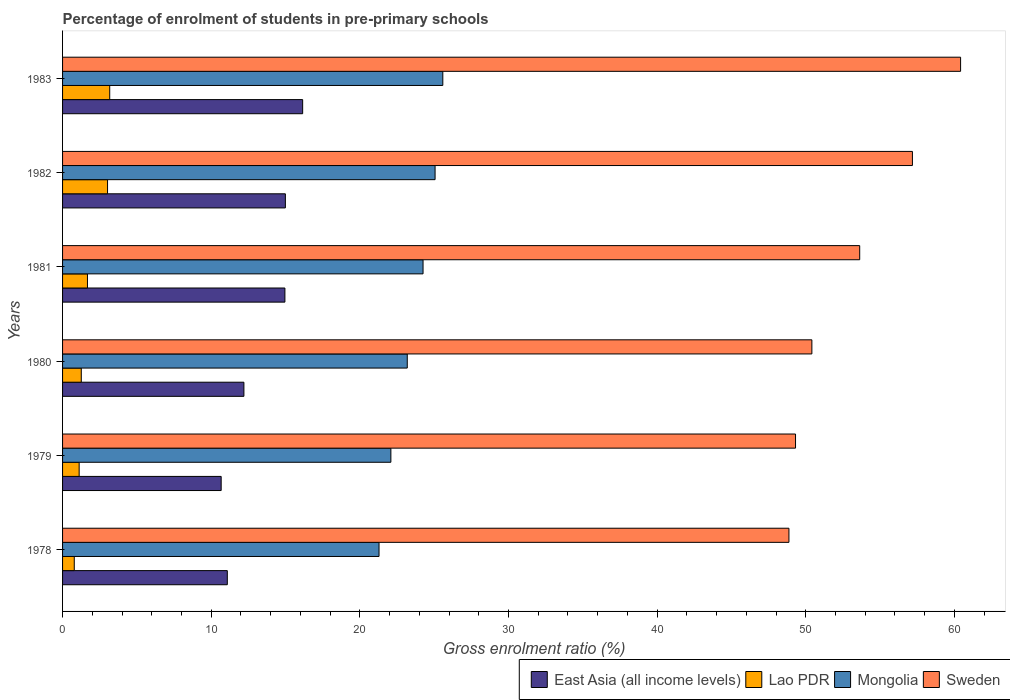How many groups of bars are there?
Ensure brevity in your answer.  6. How many bars are there on the 6th tick from the bottom?
Your response must be concise. 4. In how many cases, is the number of bars for a given year not equal to the number of legend labels?
Your answer should be compact. 0. What is the percentage of students enrolled in pre-primary schools in East Asia (all income levels) in 1981?
Your answer should be very brief. 14.96. Across all years, what is the maximum percentage of students enrolled in pre-primary schools in Mongolia?
Your answer should be compact. 25.58. Across all years, what is the minimum percentage of students enrolled in pre-primary schools in East Asia (all income levels)?
Make the answer very short. 10.67. In which year was the percentage of students enrolled in pre-primary schools in Lao PDR maximum?
Your answer should be compact. 1983. In which year was the percentage of students enrolled in pre-primary schools in Sweden minimum?
Offer a terse response. 1978. What is the total percentage of students enrolled in pre-primary schools in Sweden in the graph?
Offer a very short reply. 319.82. What is the difference between the percentage of students enrolled in pre-primary schools in Sweden in 1979 and that in 1980?
Offer a very short reply. -1.1. What is the difference between the percentage of students enrolled in pre-primary schools in Sweden in 1978 and the percentage of students enrolled in pre-primary schools in Mongolia in 1982?
Provide a succinct answer. 23.81. What is the average percentage of students enrolled in pre-primary schools in Sweden per year?
Your answer should be very brief. 53.3. In the year 1981, what is the difference between the percentage of students enrolled in pre-primary schools in Sweden and percentage of students enrolled in pre-primary schools in East Asia (all income levels)?
Keep it short and to the point. 38.67. In how many years, is the percentage of students enrolled in pre-primary schools in East Asia (all income levels) greater than 34 %?
Offer a terse response. 0. What is the ratio of the percentage of students enrolled in pre-primary schools in Mongolia in 1981 to that in 1983?
Ensure brevity in your answer.  0.95. Is the percentage of students enrolled in pre-primary schools in Mongolia in 1980 less than that in 1983?
Ensure brevity in your answer.  Yes. Is the difference between the percentage of students enrolled in pre-primary schools in Sweden in 1981 and 1982 greater than the difference between the percentage of students enrolled in pre-primary schools in East Asia (all income levels) in 1981 and 1982?
Your answer should be very brief. No. What is the difference between the highest and the second highest percentage of students enrolled in pre-primary schools in Lao PDR?
Your answer should be compact. 0.15. What is the difference between the highest and the lowest percentage of students enrolled in pre-primary schools in Lao PDR?
Your answer should be very brief. 2.38. Is the sum of the percentage of students enrolled in pre-primary schools in Sweden in 1979 and 1983 greater than the maximum percentage of students enrolled in pre-primary schools in Lao PDR across all years?
Your answer should be very brief. Yes. What does the 4th bar from the top in 1979 represents?
Provide a succinct answer. East Asia (all income levels). What does the 3rd bar from the bottom in 1983 represents?
Offer a very short reply. Mongolia. Is it the case that in every year, the sum of the percentage of students enrolled in pre-primary schools in Mongolia and percentage of students enrolled in pre-primary schools in Sweden is greater than the percentage of students enrolled in pre-primary schools in East Asia (all income levels)?
Provide a short and direct response. Yes. How many bars are there?
Provide a short and direct response. 24. Are all the bars in the graph horizontal?
Your answer should be very brief. Yes. How many years are there in the graph?
Ensure brevity in your answer.  6. Are the values on the major ticks of X-axis written in scientific E-notation?
Your answer should be compact. No. How many legend labels are there?
Provide a short and direct response. 4. How are the legend labels stacked?
Your answer should be compact. Horizontal. What is the title of the graph?
Ensure brevity in your answer.  Percentage of enrolment of students in pre-primary schools. What is the label or title of the X-axis?
Ensure brevity in your answer.  Gross enrolment ratio (%). What is the label or title of the Y-axis?
Your answer should be very brief. Years. What is the Gross enrolment ratio (%) in East Asia (all income levels) in 1978?
Your response must be concise. 11.08. What is the Gross enrolment ratio (%) in Lao PDR in 1978?
Provide a short and direct response. 0.79. What is the Gross enrolment ratio (%) of Mongolia in 1978?
Provide a short and direct response. 21.29. What is the Gross enrolment ratio (%) in Sweden in 1978?
Provide a short and direct response. 48.87. What is the Gross enrolment ratio (%) in East Asia (all income levels) in 1979?
Provide a short and direct response. 10.67. What is the Gross enrolment ratio (%) in Lao PDR in 1979?
Ensure brevity in your answer.  1.12. What is the Gross enrolment ratio (%) in Mongolia in 1979?
Provide a short and direct response. 22.09. What is the Gross enrolment ratio (%) in Sweden in 1979?
Your answer should be very brief. 49.31. What is the Gross enrolment ratio (%) in East Asia (all income levels) in 1980?
Offer a very short reply. 12.2. What is the Gross enrolment ratio (%) of Lao PDR in 1980?
Your answer should be compact. 1.26. What is the Gross enrolment ratio (%) in Mongolia in 1980?
Offer a very short reply. 23.19. What is the Gross enrolment ratio (%) in Sweden in 1980?
Your answer should be compact. 50.41. What is the Gross enrolment ratio (%) of East Asia (all income levels) in 1981?
Ensure brevity in your answer.  14.96. What is the Gross enrolment ratio (%) of Lao PDR in 1981?
Offer a terse response. 1.68. What is the Gross enrolment ratio (%) of Mongolia in 1981?
Provide a short and direct response. 24.25. What is the Gross enrolment ratio (%) in Sweden in 1981?
Ensure brevity in your answer.  53.63. What is the Gross enrolment ratio (%) in East Asia (all income levels) in 1982?
Your answer should be compact. 14.99. What is the Gross enrolment ratio (%) of Lao PDR in 1982?
Your answer should be very brief. 3.03. What is the Gross enrolment ratio (%) of Mongolia in 1982?
Make the answer very short. 25.06. What is the Gross enrolment ratio (%) in Sweden in 1982?
Your response must be concise. 57.18. What is the Gross enrolment ratio (%) of East Asia (all income levels) in 1983?
Make the answer very short. 16.15. What is the Gross enrolment ratio (%) of Lao PDR in 1983?
Your answer should be compact. 3.17. What is the Gross enrolment ratio (%) of Mongolia in 1983?
Your response must be concise. 25.58. What is the Gross enrolment ratio (%) in Sweden in 1983?
Your response must be concise. 60.42. Across all years, what is the maximum Gross enrolment ratio (%) in East Asia (all income levels)?
Your answer should be compact. 16.15. Across all years, what is the maximum Gross enrolment ratio (%) in Lao PDR?
Make the answer very short. 3.17. Across all years, what is the maximum Gross enrolment ratio (%) of Mongolia?
Give a very brief answer. 25.58. Across all years, what is the maximum Gross enrolment ratio (%) of Sweden?
Your answer should be very brief. 60.42. Across all years, what is the minimum Gross enrolment ratio (%) in East Asia (all income levels)?
Keep it short and to the point. 10.67. Across all years, what is the minimum Gross enrolment ratio (%) in Lao PDR?
Give a very brief answer. 0.79. Across all years, what is the minimum Gross enrolment ratio (%) of Mongolia?
Ensure brevity in your answer.  21.29. Across all years, what is the minimum Gross enrolment ratio (%) in Sweden?
Provide a short and direct response. 48.87. What is the total Gross enrolment ratio (%) in East Asia (all income levels) in the graph?
Provide a short and direct response. 80.06. What is the total Gross enrolment ratio (%) of Lao PDR in the graph?
Your answer should be compact. 11.04. What is the total Gross enrolment ratio (%) in Mongolia in the graph?
Offer a very short reply. 141.47. What is the total Gross enrolment ratio (%) of Sweden in the graph?
Ensure brevity in your answer.  319.82. What is the difference between the Gross enrolment ratio (%) of East Asia (all income levels) in 1978 and that in 1979?
Give a very brief answer. 0.41. What is the difference between the Gross enrolment ratio (%) of Lao PDR in 1978 and that in 1979?
Give a very brief answer. -0.33. What is the difference between the Gross enrolment ratio (%) of Mongolia in 1978 and that in 1979?
Ensure brevity in your answer.  -0.8. What is the difference between the Gross enrolment ratio (%) of Sweden in 1978 and that in 1979?
Offer a very short reply. -0.44. What is the difference between the Gross enrolment ratio (%) in East Asia (all income levels) in 1978 and that in 1980?
Provide a short and direct response. -1.12. What is the difference between the Gross enrolment ratio (%) of Lao PDR in 1978 and that in 1980?
Provide a short and direct response. -0.47. What is the difference between the Gross enrolment ratio (%) in Mongolia in 1978 and that in 1980?
Your answer should be very brief. -1.9. What is the difference between the Gross enrolment ratio (%) in Sweden in 1978 and that in 1980?
Offer a terse response. -1.54. What is the difference between the Gross enrolment ratio (%) of East Asia (all income levels) in 1978 and that in 1981?
Keep it short and to the point. -3.87. What is the difference between the Gross enrolment ratio (%) of Lao PDR in 1978 and that in 1981?
Your answer should be compact. -0.89. What is the difference between the Gross enrolment ratio (%) in Mongolia in 1978 and that in 1981?
Provide a short and direct response. -2.96. What is the difference between the Gross enrolment ratio (%) of Sweden in 1978 and that in 1981?
Make the answer very short. -4.76. What is the difference between the Gross enrolment ratio (%) in East Asia (all income levels) in 1978 and that in 1982?
Offer a very short reply. -3.91. What is the difference between the Gross enrolment ratio (%) of Lao PDR in 1978 and that in 1982?
Provide a short and direct response. -2.24. What is the difference between the Gross enrolment ratio (%) of Mongolia in 1978 and that in 1982?
Provide a short and direct response. -3.77. What is the difference between the Gross enrolment ratio (%) of Sweden in 1978 and that in 1982?
Provide a short and direct response. -8.31. What is the difference between the Gross enrolment ratio (%) of East Asia (all income levels) in 1978 and that in 1983?
Your answer should be compact. -5.07. What is the difference between the Gross enrolment ratio (%) in Lao PDR in 1978 and that in 1983?
Make the answer very short. -2.38. What is the difference between the Gross enrolment ratio (%) of Mongolia in 1978 and that in 1983?
Offer a very short reply. -4.29. What is the difference between the Gross enrolment ratio (%) in Sweden in 1978 and that in 1983?
Ensure brevity in your answer.  -11.55. What is the difference between the Gross enrolment ratio (%) in East Asia (all income levels) in 1979 and that in 1980?
Provide a succinct answer. -1.53. What is the difference between the Gross enrolment ratio (%) of Lao PDR in 1979 and that in 1980?
Keep it short and to the point. -0.14. What is the difference between the Gross enrolment ratio (%) of Mongolia in 1979 and that in 1980?
Your response must be concise. -1.1. What is the difference between the Gross enrolment ratio (%) of Sweden in 1979 and that in 1980?
Your answer should be very brief. -1.1. What is the difference between the Gross enrolment ratio (%) in East Asia (all income levels) in 1979 and that in 1981?
Offer a terse response. -4.29. What is the difference between the Gross enrolment ratio (%) in Lao PDR in 1979 and that in 1981?
Offer a very short reply. -0.56. What is the difference between the Gross enrolment ratio (%) in Mongolia in 1979 and that in 1981?
Make the answer very short. -2.16. What is the difference between the Gross enrolment ratio (%) of Sweden in 1979 and that in 1981?
Keep it short and to the point. -4.32. What is the difference between the Gross enrolment ratio (%) of East Asia (all income levels) in 1979 and that in 1982?
Give a very brief answer. -4.32. What is the difference between the Gross enrolment ratio (%) in Lao PDR in 1979 and that in 1982?
Your answer should be very brief. -1.91. What is the difference between the Gross enrolment ratio (%) in Mongolia in 1979 and that in 1982?
Offer a very short reply. -2.97. What is the difference between the Gross enrolment ratio (%) in Sweden in 1979 and that in 1982?
Provide a succinct answer. -7.86. What is the difference between the Gross enrolment ratio (%) of East Asia (all income levels) in 1979 and that in 1983?
Give a very brief answer. -5.48. What is the difference between the Gross enrolment ratio (%) of Lao PDR in 1979 and that in 1983?
Ensure brevity in your answer.  -2.06. What is the difference between the Gross enrolment ratio (%) of Mongolia in 1979 and that in 1983?
Provide a short and direct response. -3.49. What is the difference between the Gross enrolment ratio (%) in Sweden in 1979 and that in 1983?
Provide a short and direct response. -11.1. What is the difference between the Gross enrolment ratio (%) of East Asia (all income levels) in 1980 and that in 1981?
Give a very brief answer. -2.76. What is the difference between the Gross enrolment ratio (%) of Lao PDR in 1980 and that in 1981?
Make the answer very short. -0.42. What is the difference between the Gross enrolment ratio (%) of Mongolia in 1980 and that in 1981?
Your answer should be compact. -1.06. What is the difference between the Gross enrolment ratio (%) in Sweden in 1980 and that in 1981?
Ensure brevity in your answer.  -3.22. What is the difference between the Gross enrolment ratio (%) of East Asia (all income levels) in 1980 and that in 1982?
Offer a very short reply. -2.79. What is the difference between the Gross enrolment ratio (%) of Lao PDR in 1980 and that in 1982?
Provide a short and direct response. -1.77. What is the difference between the Gross enrolment ratio (%) of Mongolia in 1980 and that in 1982?
Offer a very short reply. -1.87. What is the difference between the Gross enrolment ratio (%) in Sweden in 1980 and that in 1982?
Offer a very short reply. -6.76. What is the difference between the Gross enrolment ratio (%) in East Asia (all income levels) in 1980 and that in 1983?
Provide a succinct answer. -3.95. What is the difference between the Gross enrolment ratio (%) in Lao PDR in 1980 and that in 1983?
Your answer should be very brief. -1.91. What is the difference between the Gross enrolment ratio (%) in Mongolia in 1980 and that in 1983?
Your response must be concise. -2.39. What is the difference between the Gross enrolment ratio (%) of Sweden in 1980 and that in 1983?
Offer a terse response. -10.01. What is the difference between the Gross enrolment ratio (%) in East Asia (all income levels) in 1981 and that in 1982?
Your answer should be very brief. -0.03. What is the difference between the Gross enrolment ratio (%) of Lao PDR in 1981 and that in 1982?
Your answer should be compact. -1.35. What is the difference between the Gross enrolment ratio (%) in Mongolia in 1981 and that in 1982?
Your answer should be compact. -0.81. What is the difference between the Gross enrolment ratio (%) of Sweden in 1981 and that in 1982?
Your answer should be compact. -3.55. What is the difference between the Gross enrolment ratio (%) of East Asia (all income levels) in 1981 and that in 1983?
Ensure brevity in your answer.  -1.19. What is the difference between the Gross enrolment ratio (%) of Lao PDR in 1981 and that in 1983?
Give a very brief answer. -1.5. What is the difference between the Gross enrolment ratio (%) of Mongolia in 1981 and that in 1983?
Make the answer very short. -1.33. What is the difference between the Gross enrolment ratio (%) in Sweden in 1981 and that in 1983?
Ensure brevity in your answer.  -6.79. What is the difference between the Gross enrolment ratio (%) of East Asia (all income levels) in 1982 and that in 1983?
Make the answer very short. -1.16. What is the difference between the Gross enrolment ratio (%) of Lao PDR in 1982 and that in 1983?
Keep it short and to the point. -0.15. What is the difference between the Gross enrolment ratio (%) in Mongolia in 1982 and that in 1983?
Provide a succinct answer. -0.52. What is the difference between the Gross enrolment ratio (%) of Sweden in 1982 and that in 1983?
Offer a very short reply. -3.24. What is the difference between the Gross enrolment ratio (%) in East Asia (all income levels) in 1978 and the Gross enrolment ratio (%) in Lao PDR in 1979?
Keep it short and to the point. 9.97. What is the difference between the Gross enrolment ratio (%) in East Asia (all income levels) in 1978 and the Gross enrolment ratio (%) in Mongolia in 1979?
Make the answer very short. -11. What is the difference between the Gross enrolment ratio (%) of East Asia (all income levels) in 1978 and the Gross enrolment ratio (%) of Sweden in 1979?
Your answer should be compact. -38.23. What is the difference between the Gross enrolment ratio (%) in Lao PDR in 1978 and the Gross enrolment ratio (%) in Mongolia in 1979?
Ensure brevity in your answer.  -21.3. What is the difference between the Gross enrolment ratio (%) in Lao PDR in 1978 and the Gross enrolment ratio (%) in Sweden in 1979?
Make the answer very short. -48.53. What is the difference between the Gross enrolment ratio (%) of Mongolia in 1978 and the Gross enrolment ratio (%) of Sweden in 1979?
Keep it short and to the point. -28.02. What is the difference between the Gross enrolment ratio (%) of East Asia (all income levels) in 1978 and the Gross enrolment ratio (%) of Lao PDR in 1980?
Provide a succinct answer. 9.83. What is the difference between the Gross enrolment ratio (%) of East Asia (all income levels) in 1978 and the Gross enrolment ratio (%) of Mongolia in 1980?
Offer a very short reply. -12.11. What is the difference between the Gross enrolment ratio (%) in East Asia (all income levels) in 1978 and the Gross enrolment ratio (%) in Sweden in 1980?
Ensure brevity in your answer.  -39.33. What is the difference between the Gross enrolment ratio (%) in Lao PDR in 1978 and the Gross enrolment ratio (%) in Mongolia in 1980?
Offer a terse response. -22.4. What is the difference between the Gross enrolment ratio (%) in Lao PDR in 1978 and the Gross enrolment ratio (%) in Sweden in 1980?
Your answer should be very brief. -49.62. What is the difference between the Gross enrolment ratio (%) in Mongolia in 1978 and the Gross enrolment ratio (%) in Sweden in 1980?
Ensure brevity in your answer.  -29.12. What is the difference between the Gross enrolment ratio (%) in East Asia (all income levels) in 1978 and the Gross enrolment ratio (%) in Lao PDR in 1981?
Your answer should be very brief. 9.41. What is the difference between the Gross enrolment ratio (%) of East Asia (all income levels) in 1978 and the Gross enrolment ratio (%) of Mongolia in 1981?
Provide a succinct answer. -13.17. What is the difference between the Gross enrolment ratio (%) in East Asia (all income levels) in 1978 and the Gross enrolment ratio (%) in Sweden in 1981?
Give a very brief answer. -42.55. What is the difference between the Gross enrolment ratio (%) in Lao PDR in 1978 and the Gross enrolment ratio (%) in Mongolia in 1981?
Offer a very short reply. -23.46. What is the difference between the Gross enrolment ratio (%) of Lao PDR in 1978 and the Gross enrolment ratio (%) of Sweden in 1981?
Offer a terse response. -52.84. What is the difference between the Gross enrolment ratio (%) of Mongolia in 1978 and the Gross enrolment ratio (%) of Sweden in 1981?
Provide a succinct answer. -32.34. What is the difference between the Gross enrolment ratio (%) of East Asia (all income levels) in 1978 and the Gross enrolment ratio (%) of Lao PDR in 1982?
Offer a terse response. 8.06. What is the difference between the Gross enrolment ratio (%) in East Asia (all income levels) in 1978 and the Gross enrolment ratio (%) in Mongolia in 1982?
Give a very brief answer. -13.98. What is the difference between the Gross enrolment ratio (%) in East Asia (all income levels) in 1978 and the Gross enrolment ratio (%) in Sweden in 1982?
Your answer should be compact. -46.09. What is the difference between the Gross enrolment ratio (%) in Lao PDR in 1978 and the Gross enrolment ratio (%) in Mongolia in 1982?
Provide a short and direct response. -24.27. What is the difference between the Gross enrolment ratio (%) of Lao PDR in 1978 and the Gross enrolment ratio (%) of Sweden in 1982?
Give a very brief answer. -56.39. What is the difference between the Gross enrolment ratio (%) in Mongolia in 1978 and the Gross enrolment ratio (%) in Sweden in 1982?
Your answer should be very brief. -35.88. What is the difference between the Gross enrolment ratio (%) of East Asia (all income levels) in 1978 and the Gross enrolment ratio (%) of Lao PDR in 1983?
Your answer should be very brief. 7.91. What is the difference between the Gross enrolment ratio (%) in East Asia (all income levels) in 1978 and the Gross enrolment ratio (%) in Mongolia in 1983?
Your response must be concise. -14.5. What is the difference between the Gross enrolment ratio (%) in East Asia (all income levels) in 1978 and the Gross enrolment ratio (%) in Sweden in 1983?
Offer a very short reply. -49.33. What is the difference between the Gross enrolment ratio (%) of Lao PDR in 1978 and the Gross enrolment ratio (%) of Mongolia in 1983?
Ensure brevity in your answer.  -24.79. What is the difference between the Gross enrolment ratio (%) in Lao PDR in 1978 and the Gross enrolment ratio (%) in Sweden in 1983?
Offer a terse response. -59.63. What is the difference between the Gross enrolment ratio (%) of Mongolia in 1978 and the Gross enrolment ratio (%) of Sweden in 1983?
Make the answer very short. -39.13. What is the difference between the Gross enrolment ratio (%) of East Asia (all income levels) in 1979 and the Gross enrolment ratio (%) of Lao PDR in 1980?
Your response must be concise. 9.41. What is the difference between the Gross enrolment ratio (%) of East Asia (all income levels) in 1979 and the Gross enrolment ratio (%) of Mongolia in 1980?
Keep it short and to the point. -12.52. What is the difference between the Gross enrolment ratio (%) of East Asia (all income levels) in 1979 and the Gross enrolment ratio (%) of Sweden in 1980?
Your response must be concise. -39.74. What is the difference between the Gross enrolment ratio (%) in Lao PDR in 1979 and the Gross enrolment ratio (%) in Mongolia in 1980?
Offer a very short reply. -22.07. What is the difference between the Gross enrolment ratio (%) of Lao PDR in 1979 and the Gross enrolment ratio (%) of Sweden in 1980?
Your answer should be very brief. -49.3. What is the difference between the Gross enrolment ratio (%) of Mongolia in 1979 and the Gross enrolment ratio (%) of Sweden in 1980?
Your answer should be compact. -28.32. What is the difference between the Gross enrolment ratio (%) in East Asia (all income levels) in 1979 and the Gross enrolment ratio (%) in Lao PDR in 1981?
Provide a succinct answer. 9. What is the difference between the Gross enrolment ratio (%) of East Asia (all income levels) in 1979 and the Gross enrolment ratio (%) of Mongolia in 1981?
Your answer should be very brief. -13.58. What is the difference between the Gross enrolment ratio (%) in East Asia (all income levels) in 1979 and the Gross enrolment ratio (%) in Sweden in 1981?
Keep it short and to the point. -42.96. What is the difference between the Gross enrolment ratio (%) in Lao PDR in 1979 and the Gross enrolment ratio (%) in Mongolia in 1981?
Give a very brief answer. -23.14. What is the difference between the Gross enrolment ratio (%) of Lao PDR in 1979 and the Gross enrolment ratio (%) of Sweden in 1981?
Your answer should be very brief. -52.51. What is the difference between the Gross enrolment ratio (%) in Mongolia in 1979 and the Gross enrolment ratio (%) in Sweden in 1981?
Keep it short and to the point. -31.54. What is the difference between the Gross enrolment ratio (%) in East Asia (all income levels) in 1979 and the Gross enrolment ratio (%) in Lao PDR in 1982?
Offer a very short reply. 7.64. What is the difference between the Gross enrolment ratio (%) in East Asia (all income levels) in 1979 and the Gross enrolment ratio (%) in Mongolia in 1982?
Offer a terse response. -14.39. What is the difference between the Gross enrolment ratio (%) in East Asia (all income levels) in 1979 and the Gross enrolment ratio (%) in Sweden in 1982?
Give a very brief answer. -46.51. What is the difference between the Gross enrolment ratio (%) in Lao PDR in 1979 and the Gross enrolment ratio (%) in Mongolia in 1982?
Your response must be concise. -23.95. What is the difference between the Gross enrolment ratio (%) of Lao PDR in 1979 and the Gross enrolment ratio (%) of Sweden in 1982?
Offer a terse response. -56.06. What is the difference between the Gross enrolment ratio (%) of Mongolia in 1979 and the Gross enrolment ratio (%) of Sweden in 1982?
Your response must be concise. -35.09. What is the difference between the Gross enrolment ratio (%) of East Asia (all income levels) in 1979 and the Gross enrolment ratio (%) of Lao PDR in 1983?
Provide a succinct answer. 7.5. What is the difference between the Gross enrolment ratio (%) of East Asia (all income levels) in 1979 and the Gross enrolment ratio (%) of Mongolia in 1983?
Give a very brief answer. -14.91. What is the difference between the Gross enrolment ratio (%) of East Asia (all income levels) in 1979 and the Gross enrolment ratio (%) of Sweden in 1983?
Provide a succinct answer. -49.75. What is the difference between the Gross enrolment ratio (%) of Lao PDR in 1979 and the Gross enrolment ratio (%) of Mongolia in 1983?
Offer a terse response. -24.47. What is the difference between the Gross enrolment ratio (%) of Lao PDR in 1979 and the Gross enrolment ratio (%) of Sweden in 1983?
Offer a terse response. -59.3. What is the difference between the Gross enrolment ratio (%) of Mongolia in 1979 and the Gross enrolment ratio (%) of Sweden in 1983?
Offer a very short reply. -38.33. What is the difference between the Gross enrolment ratio (%) in East Asia (all income levels) in 1980 and the Gross enrolment ratio (%) in Lao PDR in 1981?
Offer a very short reply. 10.53. What is the difference between the Gross enrolment ratio (%) of East Asia (all income levels) in 1980 and the Gross enrolment ratio (%) of Mongolia in 1981?
Your answer should be very brief. -12.05. What is the difference between the Gross enrolment ratio (%) in East Asia (all income levels) in 1980 and the Gross enrolment ratio (%) in Sweden in 1981?
Offer a terse response. -41.43. What is the difference between the Gross enrolment ratio (%) in Lao PDR in 1980 and the Gross enrolment ratio (%) in Mongolia in 1981?
Ensure brevity in your answer.  -22.99. What is the difference between the Gross enrolment ratio (%) of Lao PDR in 1980 and the Gross enrolment ratio (%) of Sweden in 1981?
Make the answer very short. -52.37. What is the difference between the Gross enrolment ratio (%) in Mongolia in 1980 and the Gross enrolment ratio (%) in Sweden in 1981?
Your answer should be compact. -30.44. What is the difference between the Gross enrolment ratio (%) in East Asia (all income levels) in 1980 and the Gross enrolment ratio (%) in Lao PDR in 1982?
Give a very brief answer. 9.17. What is the difference between the Gross enrolment ratio (%) in East Asia (all income levels) in 1980 and the Gross enrolment ratio (%) in Mongolia in 1982?
Give a very brief answer. -12.86. What is the difference between the Gross enrolment ratio (%) of East Asia (all income levels) in 1980 and the Gross enrolment ratio (%) of Sweden in 1982?
Your answer should be compact. -44.98. What is the difference between the Gross enrolment ratio (%) in Lao PDR in 1980 and the Gross enrolment ratio (%) in Mongolia in 1982?
Offer a terse response. -23.8. What is the difference between the Gross enrolment ratio (%) of Lao PDR in 1980 and the Gross enrolment ratio (%) of Sweden in 1982?
Your answer should be compact. -55.92. What is the difference between the Gross enrolment ratio (%) in Mongolia in 1980 and the Gross enrolment ratio (%) in Sweden in 1982?
Provide a succinct answer. -33.99. What is the difference between the Gross enrolment ratio (%) of East Asia (all income levels) in 1980 and the Gross enrolment ratio (%) of Lao PDR in 1983?
Provide a succinct answer. 9.03. What is the difference between the Gross enrolment ratio (%) of East Asia (all income levels) in 1980 and the Gross enrolment ratio (%) of Mongolia in 1983?
Offer a very short reply. -13.38. What is the difference between the Gross enrolment ratio (%) of East Asia (all income levels) in 1980 and the Gross enrolment ratio (%) of Sweden in 1983?
Make the answer very short. -48.22. What is the difference between the Gross enrolment ratio (%) of Lao PDR in 1980 and the Gross enrolment ratio (%) of Mongolia in 1983?
Provide a succinct answer. -24.32. What is the difference between the Gross enrolment ratio (%) of Lao PDR in 1980 and the Gross enrolment ratio (%) of Sweden in 1983?
Provide a succinct answer. -59.16. What is the difference between the Gross enrolment ratio (%) in Mongolia in 1980 and the Gross enrolment ratio (%) in Sweden in 1983?
Your answer should be compact. -37.23. What is the difference between the Gross enrolment ratio (%) of East Asia (all income levels) in 1981 and the Gross enrolment ratio (%) of Lao PDR in 1982?
Keep it short and to the point. 11.93. What is the difference between the Gross enrolment ratio (%) in East Asia (all income levels) in 1981 and the Gross enrolment ratio (%) in Mongolia in 1982?
Keep it short and to the point. -10.1. What is the difference between the Gross enrolment ratio (%) of East Asia (all income levels) in 1981 and the Gross enrolment ratio (%) of Sweden in 1982?
Offer a very short reply. -42.22. What is the difference between the Gross enrolment ratio (%) of Lao PDR in 1981 and the Gross enrolment ratio (%) of Mongolia in 1982?
Offer a terse response. -23.39. What is the difference between the Gross enrolment ratio (%) of Lao PDR in 1981 and the Gross enrolment ratio (%) of Sweden in 1982?
Make the answer very short. -55.5. What is the difference between the Gross enrolment ratio (%) of Mongolia in 1981 and the Gross enrolment ratio (%) of Sweden in 1982?
Offer a terse response. -32.92. What is the difference between the Gross enrolment ratio (%) of East Asia (all income levels) in 1981 and the Gross enrolment ratio (%) of Lao PDR in 1983?
Offer a terse response. 11.79. What is the difference between the Gross enrolment ratio (%) of East Asia (all income levels) in 1981 and the Gross enrolment ratio (%) of Mongolia in 1983?
Provide a short and direct response. -10.62. What is the difference between the Gross enrolment ratio (%) of East Asia (all income levels) in 1981 and the Gross enrolment ratio (%) of Sweden in 1983?
Your answer should be very brief. -45.46. What is the difference between the Gross enrolment ratio (%) of Lao PDR in 1981 and the Gross enrolment ratio (%) of Mongolia in 1983?
Your answer should be compact. -23.91. What is the difference between the Gross enrolment ratio (%) in Lao PDR in 1981 and the Gross enrolment ratio (%) in Sweden in 1983?
Provide a short and direct response. -58.74. What is the difference between the Gross enrolment ratio (%) of Mongolia in 1981 and the Gross enrolment ratio (%) of Sweden in 1983?
Give a very brief answer. -36.17. What is the difference between the Gross enrolment ratio (%) of East Asia (all income levels) in 1982 and the Gross enrolment ratio (%) of Lao PDR in 1983?
Provide a short and direct response. 11.82. What is the difference between the Gross enrolment ratio (%) of East Asia (all income levels) in 1982 and the Gross enrolment ratio (%) of Mongolia in 1983?
Offer a very short reply. -10.59. What is the difference between the Gross enrolment ratio (%) in East Asia (all income levels) in 1982 and the Gross enrolment ratio (%) in Sweden in 1983?
Offer a very short reply. -45.43. What is the difference between the Gross enrolment ratio (%) of Lao PDR in 1982 and the Gross enrolment ratio (%) of Mongolia in 1983?
Provide a succinct answer. -22.56. What is the difference between the Gross enrolment ratio (%) in Lao PDR in 1982 and the Gross enrolment ratio (%) in Sweden in 1983?
Give a very brief answer. -57.39. What is the difference between the Gross enrolment ratio (%) of Mongolia in 1982 and the Gross enrolment ratio (%) of Sweden in 1983?
Keep it short and to the point. -35.36. What is the average Gross enrolment ratio (%) of East Asia (all income levels) per year?
Provide a short and direct response. 13.34. What is the average Gross enrolment ratio (%) of Lao PDR per year?
Ensure brevity in your answer.  1.84. What is the average Gross enrolment ratio (%) in Mongolia per year?
Offer a very short reply. 23.58. What is the average Gross enrolment ratio (%) in Sweden per year?
Keep it short and to the point. 53.3. In the year 1978, what is the difference between the Gross enrolment ratio (%) in East Asia (all income levels) and Gross enrolment ratio (%) in Lao PDR?
Make the answer very short. 10.3. In the year 1978, what is the difference between the Gross enrolment ratio (%) of East Asia (all income levels) and Gross enrolment ratio (%) of Mongolia?
Offer a terse response. -10.21. In the year 1978, what is the difference between the Gross enrolment ratio (%) in East Asia (all income levels) and Gross enrolment ratio (%) in Sweden?
Offer a terse response. -37.79. In the year 1978, what is the difference between the Gross enrolment ratio (%) in Lao PDR and Gross enrolment ratio (%) in Mongolia?
Your answer should be very brief. -20.5. In the year 1978, what is the difference between the Gross enrolment ratio (%) in Lao PDR and Gross enrolment ratio (%) in Sweden?
Make the answer very short. -48.08. In the year 1978, what is the difference between the Gross enrolment ratio (%) of Mongolia and Gross enrolment ratio (%) of Sweden?
Give a very brief answer. -27.58. In the year 1979, what is the difference between the Gross enrolment ratio (%) in East Asia (all income levels) and Gross enrolment ratio (%) in Lao PDR?
Provide a succinct answer. 9.55. In the year 1979, what is the difference between the Gross enrolment ratio (%) in East Asia (all income levels) and Gross enrolment ratio (%) in Mongolia?
Offer a very short reply. -11.42. In the year 1979, what is the difference between the Gross enrolment ratio (%) in East Asia (all income levels) and Gross enrolment ratio (%) in Sweden?
Your answer should be very brief. -38.64. In the year 1979, what is the difference between the Gross enrolment ratio (%) in Lao PDR and Gross enrolment ratio (%) in Mongolia?
Provide a succinct answer. -20.97. In the year 1979, what is the difference between the Gross enrolment ratio (%) in Lao PDR and Gross enrolment ratio (%) in Sweden?
Provide a succinct answer. -48.2. In the year 1979, what is the difference between the Gross enrolment ratio (%) in Mongolia and Gross enrolment ratio (%) in Sweden?
Provide a succinct answer. -27.22. In the year 1980, what is the difference between the Gross enrolment ratio (%) of East Asia (all income levels) and Gross enrolment ratio (%) of Lao PDR?
Your answer should be compact. 10.94. In the year 1980, what is the difference between the Gross enrolment ratio (%) of East Asia (all income levels) and Gross enrolment ratio (%) of Mongolia?
Your answer should be compact. -10.99. In the year 1980, what is the difference between the Gross enrolment ratio (%) of East Asia (all income levels) and Gross enrolment ratio (%) of Sweden?
Your answer should be compact. -38.21. In the year 1980, what is the difference between the Gross enrolment ratio (%) of Lao PDR and Gross enrolment ratio (%) of Mongolia?
Your answer should be very brief. -21.93. In the year 1980, what is the difference between the Gross enrolment ratio (%) of Lao PDR and Gross enrolment ratio (%) of Sweden?
Give a very brief answer. -49.15. In the year 1980, what is the difference between the Gross enrolment ratio (%) in Mongolia and Gross enrolment ratio (%) in Sweden?
Provide a succinct answer. -27.22. In the year 1981, what is the difference between the Gross enrolment ratio (%) in East Asia (all income levels) and Gross enrolment ratio (%) in Lao PDR?
Offer a terse response. 13.28. In the year 1981, what is the difference between the Gross enrolment ratio (%) of East Asia (all income levels) and Gross enrolment ratio (%) of Mongolia?
Your answer should be compact. -9.29. In the year 1981, what is the difference between the Gross enrolment ratio (%) in East Asia (all income levels) and Gross enrolment ratio (%) in Sweden?
Your answer should be compact. -38.67. In the year 1981, what is the difference between the Gross enrolment ratio (%) of Lao PDR and Gross enrolment ratio (%) of Mongolia?
Offer a very short reply. -22.58. In the year 1981, what is the difference between the Gross enrolment ratio (%) of Lao PDR and Gross enrolment ratio (%) of Sweden?
Your answer should be very brief. -51.96. In the year 1981, what is the difference between the Gross enrolment ratio (%) in Mongolia and Gross enrolment ratio (%) in Sweden?
Provide a succinct answer. -29.38. In the year 1982, what is the difference between the Gross enrolment ratio (%) of East Asia (all income levels) and Gross enrolment ratio (%) of Lao PDR?
Your answer should be compact. 11.96. In the year 1982, what is the difference between the Gross enrolment ratio (%) of East Asia (all income levels) and Gross enrolment ratio (%) of Mongolia?
Provide a succinct answer. -10.07. In the year 1982, what is the difference between the Gross enrolment ratio (%) in East Asia (all income levels) and Gross enrolment ratio (%) in Sweden?
Offer a terse response. -42.19. In the year 1982, what is the difference between the Gross enrolment ratio (%) in Lao PDR and Gross enrolment ratio (%) in Mongolia?
Your response must be concise. -22.04. In the year 1982, what is the difference between the Gross enrolment ratio (%) of Lao PDR and Gross enrolment ratio (%) of Sweden?
Give a very brief answer. -54.15. In the year 1982, what is the difference between the Gross enrolment ratio (%) of Mongolia and Gross enrolment ratio (%) of Sweden?
Give a very brief answer. -32.11. In the year 1983, what is the difference between the Gross enrolment ratio (%) in East Asia (all income levels) and Gross enrolment ratio (%) in Lao PDR?
Give a very brief answer. 12.98. In the year 1983, what is the difference between the Gross enrolment ratio (%) of East Asia (all income levels) and Gross enrolment ratio (%) of Mongolia?
Your answer should be compact. -9.43. In the year 1983, what is the difference between the Gross enrolment ratio (%) of East Asia (all income levels) and Gross enrolment ratio (%) of Sweden?
Offer a terse response. -44.27. In the year 1983, what is the difference between the Gross enrolment ratio (%) of Lao PDR and Gross enrolment ratio (%) of Mongolia?
Your response must be concise. -22.41. In the year 1983, what is the difference between the Gross enrolment ratio (%) of Lao PDR and Gross enrolment ratio (%) of Sweden?
Keep it short and to the point. -57.25. In the year 1983, what is the difference between the Gross enrolment ratio (%) in Mongolia and Gross enrolment ratio (%) in Sweden?
Ensure brevity in your answer.  -34.84. What is the ratio of the Gross enrolment ratio (%) of East Asia (all income levels) in 1978 to that in 1979?
Make the answer very short. 1.04. What is the ratio of the Gross enrolment ratio (%) of Lao PDR in 1978 to that in 1979?
Keep it short and to the point. 0.71. What is the ratio of the Gross enrolment ratio (%) in Mongolia in 1978 to that in 1979?
Your answer should be compact. 0.96. What is the ratio of the Gross enrolment ratio (%) of Sweden in 1978 to that in 1979?
Offer a terse response. 0.99. What is the ratio of the Gross enrolment ratio (%) of East Asia (all income levels) in 1978 to that in 1980?
Provide a succinct answer. 0.91. What is the ratio of the Gross enrolment ratio (%) in Lao PDR in 1978 to that in 1980?
Provide a short and direct response. 0.63. What is the ratio of the Gross enrolment ratio (%) in Mongolia in 1978 to that in 1980?
Ensure brevity in your answer.  0.92. What is the ratio of the Gross enrolment ratio (%) of Sweden in 1978 to that in 1980?
Offer a terse response. 0.97. What is the ratio of the Gross enrolment ratio (%) in East Asia (all income levels) in 1978 to that in 1981?
Provide a short and direct response. 0.74. What is the ratio of the Gross enrolment ratio (%) of Lao PDR in 1978 to that in 1981?
Keep it short and to the point. 0.47. What is the ratio of the Gross enrolment ratio (%) of Mongolia in 1978 to that in 1981?
Offer a terse response. 0.88. What is the ratio of the Gross enrolment ratio (%) of Sweden in 1978 to that in 1981?
Your answer should be very brief. 0.91. What is the ratio of the Gross enrolment ratio (%) of East Asia (all income levels) in 1978 to that in 1982?
Your answer should be very brief. 0.74. What is the ratio of the Gross enrolment ratio (%) of Lao PDR in 1978 to that in 1982?
Offer a terse response. 0.26. What is the ratio of the Gross enrolment ratio (%) in Mongolia in 1978 to that in 1982?
Offer a terse response. 0.85. What is the ratio of the Gross enrolment ratio (%) of Sweden in 1978 to that in 1982?
Give a very brief answer. 0.85. What is the ratio of the Gross enrolment ratio (%) in East Asia (all income levels) in 1978 to that in 1983?
Your answer should be very brief. 0.69. What is the ratio of the Gross enrolment ratio (%) in Lao PDR in 1978 to that in 1983?
Offer a terse response. 0.25. What is the ratio of the Gross enrolment ratio (%) in Mongolia in 1978 to that in 1983?
Your response must be concise. 0.83. What is the ratio of the Gross enrolment ratio (%) in Sweden in 1978 to that in 1983?
Your answer should be compact. 0.81. What is the ratio of the Gross enrolment ratio (%) in East Asia (all income levels) in 1979 to that in 1980?
Your answer should be compact. 0.87. What is the ratio of the Gross enrolment ratio (%) of Lao PDR in 1979 to that in 1980?
Your answer should be compact. 0.89. What is the ratio of the Gross enrolment ratio (%) in Sweden in 1979 to that in 1980?
Offer a terse response. 0.98. What is the ratio of the Gross enrolment ratio (%) in East Asia (all income levels) in 1979 to that in 1981?
Your answer should be compact. 0.71. What is the ratio of the Gross enrolment ratio (%) in Lao PDR in 1979 to that in 1981?
Give a very brief answer. 0.67. What is the ratio of the Gross enrolment ratio (%) in Mongolia in 1979 to that in 1981?
Give a very brief answer. 0.91. What is the ratio of the Gross enrolment ratio (%) in Sweden in 1979 to that in 1981?
Give a very brief answer. 0.92. What is the ratio of the Gross enrolment ratio (%) of East Asia (all income levels) in 1979 to that in 1982?
Offer a very short reply. 0.71. What is the ratio of the Gross enrolment ratio (%) of Lao PDR in 1979 to that in 1982?
Give a very brief answer. 0.37. What is the ratio of the Gross enrolment ratio (%) in Mongolia in 1979 to that in 1982?
Offer a terse response. 0.88. What is the ratio of the Gross enrolment ratio (%) in Sweden in 1979 to that in 1982?
Offer a terse response. 0.86. What is the ratio of the Gross enrolment ratio (%) in East Asia (all income levels) in 1979 to that in 1983?
Provide a short and direct response. 0.66. What is the ratio of the Gross enrolment ratio (%) of Lao PDR in 1979 to that in 1983?
Give a very brief answer. 0.35. What is the ratio of the Gross enrolment ratio (%) in Mongolia in 1979 to that in 1983?
Your answer should be very brief. 0.86. What is the ratio of the Gross enrolment ratio (%) of Sweden in 1979 to that in 1983?
Your answer should be very brief. 0.82. What is the ratio of the Gross enrolment ratio (%) in East Asia (all income levels) in 1980 to that in 1981?
Make the answer very short. 0.82. What is the ratio of the Gross enrolment ratio (%) of Lao PDR in 1980 to that in 1981?
Your answer should be compact. 0.75. What is the ratio of the Gross enrolment ratio (%) of Mongolia in 1980 to that in 1981?
Ensure brevity in your answer.  0.96. What is the ratio of the Gross enrolment ratio (%) in Sweden in 1980 to that in 1981?
Your answer should be very brief. 0.94. What is the ratio of the Gross enrolment ratio (%) of East Asia (all income levels) in 1980 to that in 1982?
Provide a short and direct response. 0.81. What is the ratio of the Gross enrolment ratio (%) of Lao PDR in 1980 to that in 1982?
Provide a succinct answer. 0.42. What is the ratio of the Gross enrolment ratio (%) in Mongolia in 1980 to that in 1982?
Ensure brevity in your answer.  0.93. What is the ratio of the Gross enrolment ratio (%) in Sweden in 1980 to that in 1982?
Offer a terse response. 0.88. What is the ratio of the Gross enrolment ratio (%) in East Asia (all income levels) in 1980 to that in 1983?
Ensure brevity in your answer.  0.76. What is the ratio of the Gross enrolment ratio (%) of Lao PDR in 1980 to that in 1983?
Your response must be concise. 0.4. What is the ratio of the Gross enrolment ratio (%) of Mongolia in 1980 to that in 1983?
Provide a succinct answer. 0.91. What is the ratio of the Gross enrolment ratio (%) of Sweden in 1980 to that in 1983?
Your answer should be very brief. 0.83. What is the ratio of the Gross enrolment ratio (%) of East Asia (all income levels) in 1981 to that in 1982?
Provide a succinct answer. 1. What is the ratio of the Gross enrolment ratio (%) of Lao PDR in 1981 to that in 1982?
Your answer should be compact. 0.55. What is the ratio of the Gross enrolment ratio (%) of Mongolia in 1981 to that in 1982?
Offer a very short reply. 0.97. What is the ratio of the Gross enrolment ratio (%) of Sweden in 1981 to that in 1982?
Offer a terse response. 0.94. What is the ratio of the Gross enrolment ratio (%) in East Asia (all income levels) in 1981 to that in 1983?
Ensure brevity in your answer.  0.93. What is the ratio of the Gross enrolment ratio (%) in Lao PDR in 1981 to that in 1983?
Keep it short and to the point. 0.53. What is the ratio of the Gross enrolment ratio (%) of Mongolia in 1981 to that in 1983?
Make the answer very short. 0.95. What is the ratio of the Gross enrolment ratio (%) of Sweden in 1981 to that in 1983?
Your response must be concise. 0.89. What is the ratio of the Gross enrolment ratio (%) in East Asia (all income levels) in 1982 to that in 1983?
Your answer should be compact. 0.93. What is the ratio of the Gross enrolment ratio (%) of Lao PDR in 1982 to that in 1983?
Your answer should be very brief. 0.95. What is the ratio of the Gross enrolment ratio (%) of Mongolia in 1982 to that in 1983?
Your response must be concise. 0.98. What is the ratio of the Gross enrolment ratio (%) of Sweden in 1982 to that in 1983?
Give a very brief answer. 0.95. What is the difference between the highest and the second highest Gross enrolment ratio (%) in East Asia (all income levels)?
Provide a succinct answer. 1.16. What is the difference between the highest and the second highest Gross enrolment ratio (%) in Lao PDR?
Provide a short and direct response. 0.15. What is the difference between the highest and the second highest Gross enrolment ratio (%) of Mongolia?
Keep it short and to the point. 0.52. What is the difference between the highest and the second highest Gross enrolment ratio (%) of Sweden?
Ensure brevity in your answer.  3.24. What is the difference between the highest and the lowest Gross enrolment ratio (%) of East Asia (all income levels)?
Provide a succinct answer. 5.48. What is the difference between the highest and the lowest Gross enrolment ratio (%) in Lao PDR?
Provide a succinct answer. 2.38. What is the difference between the highest and the lowest Gross enrolment ratio (%) of Mongolia?
Ensure brevity in your answer.  4.29. What is the difference between the highest and the lowest Gross enrolment ratio (%) in Sweden?
Offer a terse response. 11.55. 